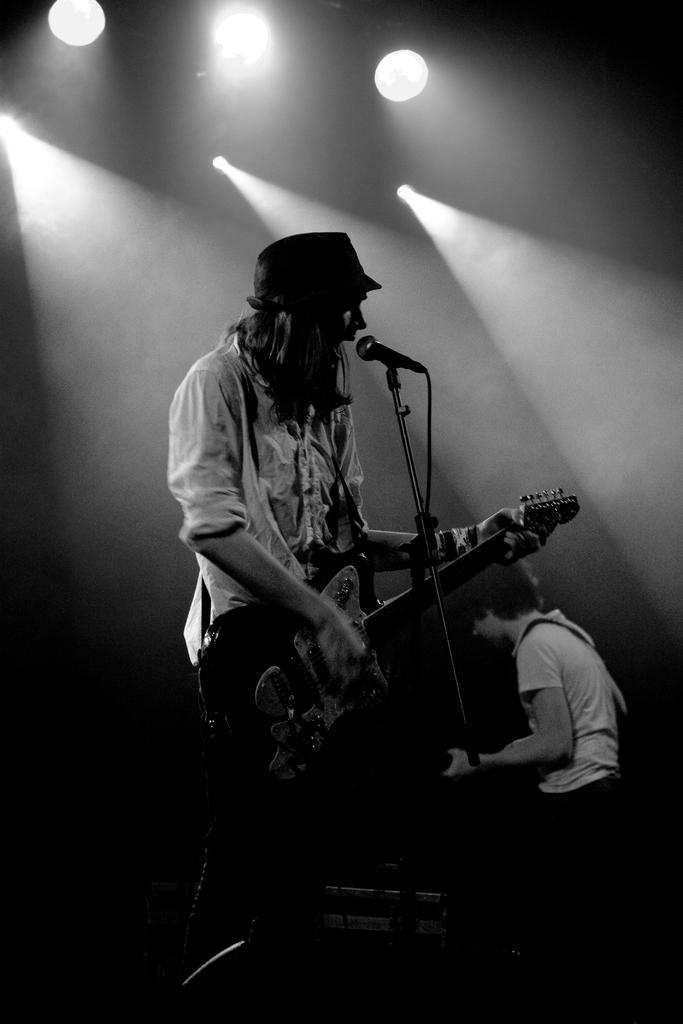Describe this image in one or two sentences. In this image, In the middle there is a man standing and holding a music instrument and there is a microphone which is in black color, In the right side there is a man sitting, In the background there are some light which are in white color. 